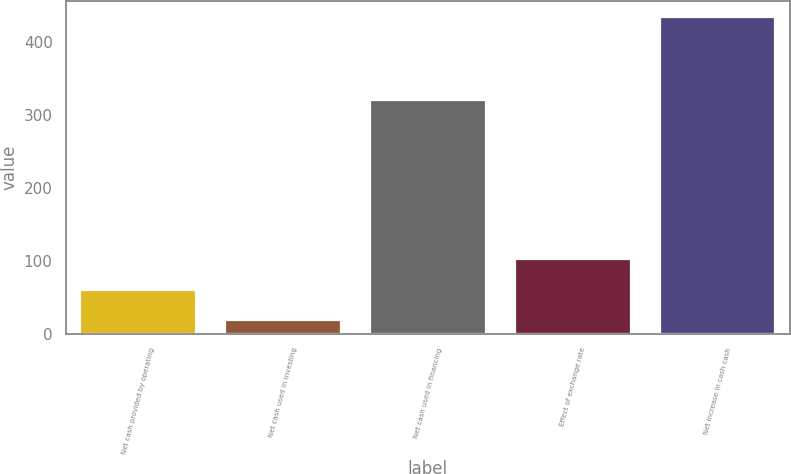<chart> <loc_0><loc_0><loc_500><loc_500><bar_chart><fcel>Net cash provided by operating<fcel>Net cash used in investing<fcel>Net cash used in financing<fcel>Effect of exchange rate<fcel>Net increase in cash cash<nl><fcel>60.5<fcel>19<fcel>320.9<fcel>102<fcel>434<nl></chart> 